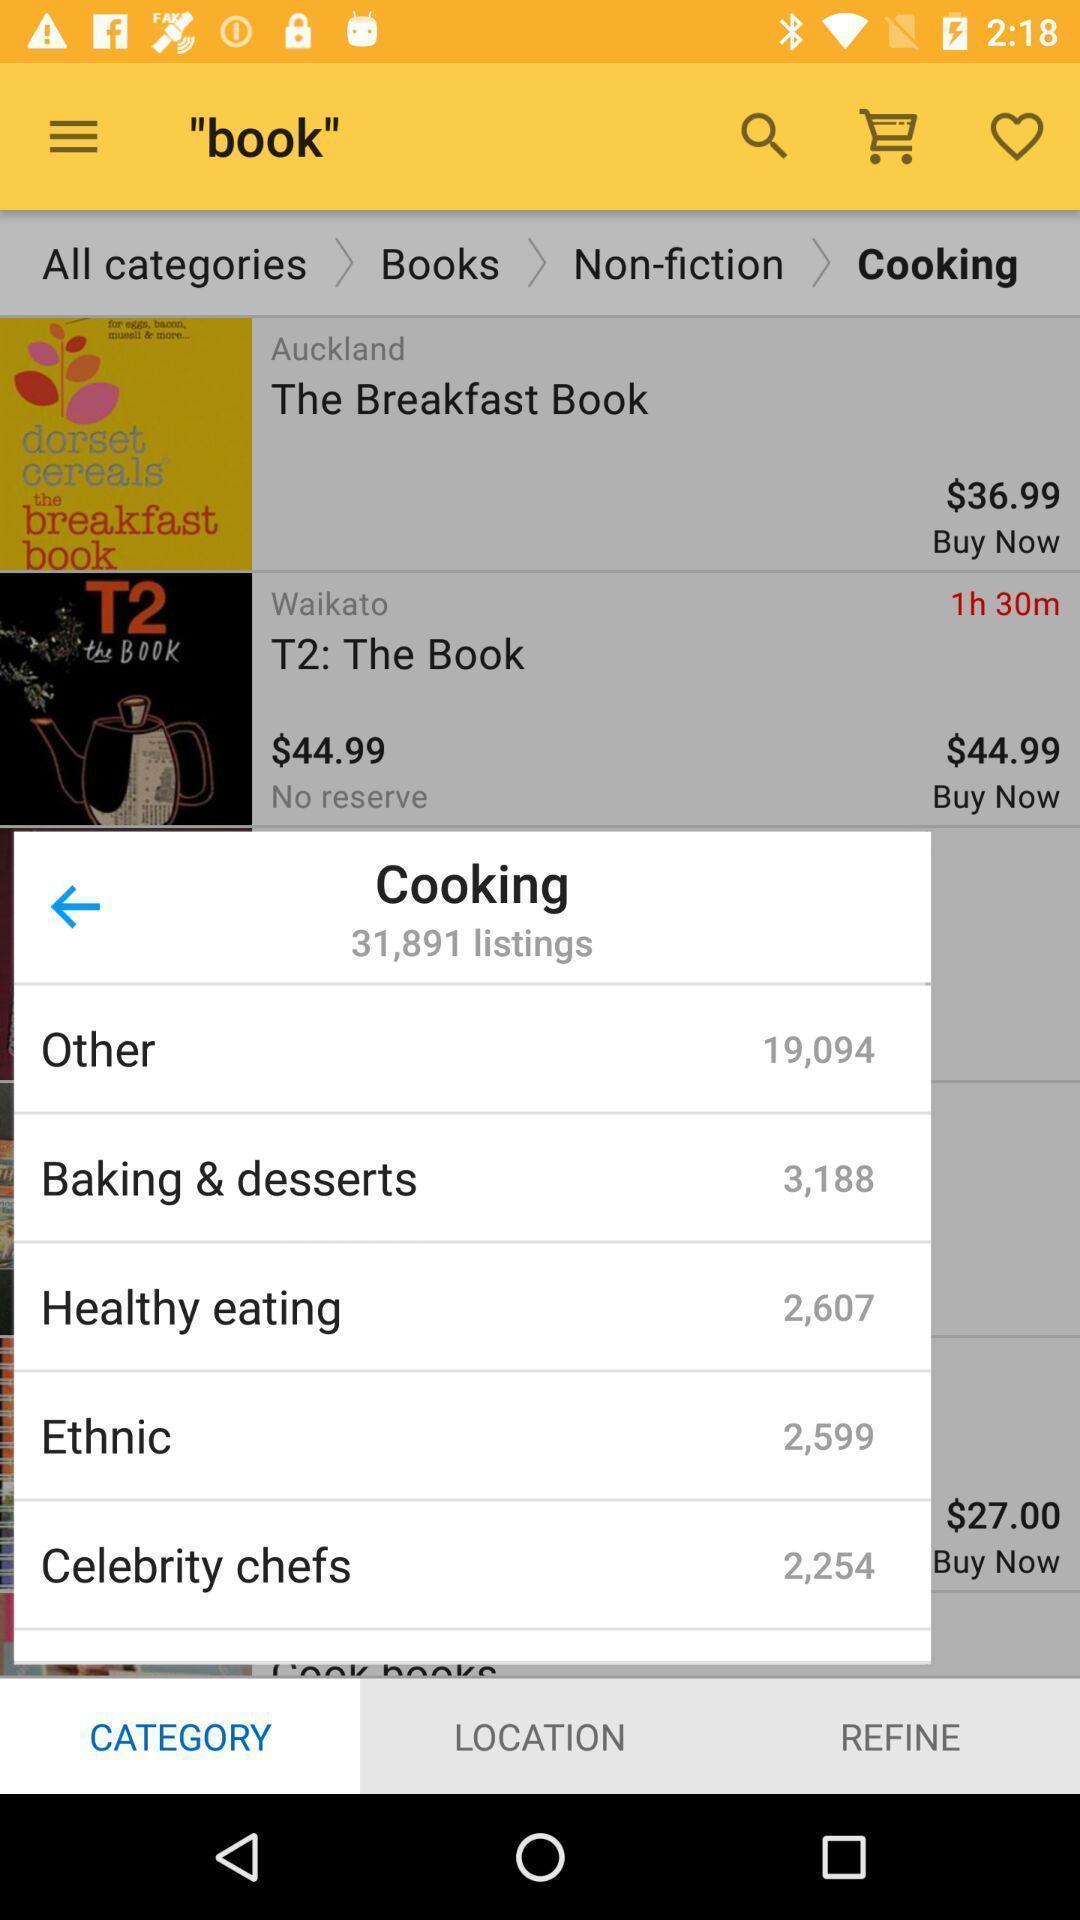Give me a summary of this screen capture. Pop up showing list of cooking categories. 